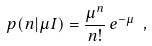<formula> <loc_0><loc_0><loc_500><loc_500>p ( n | \mu I ) = \frac { \mu ^ { n } } { n ! } \, e ^ { - \mu } \ ,</formula> 